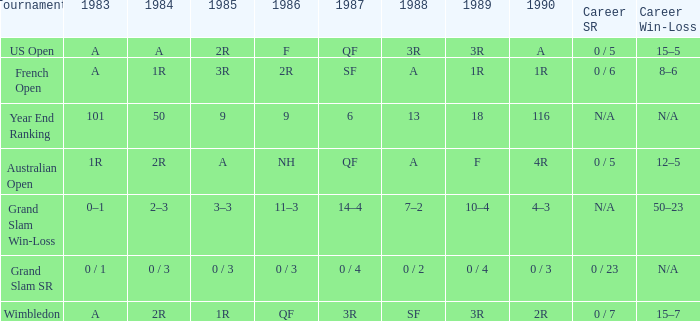What is the 1987 results when the results of 1989 is 3R, and the 1986 results is F? QF. 